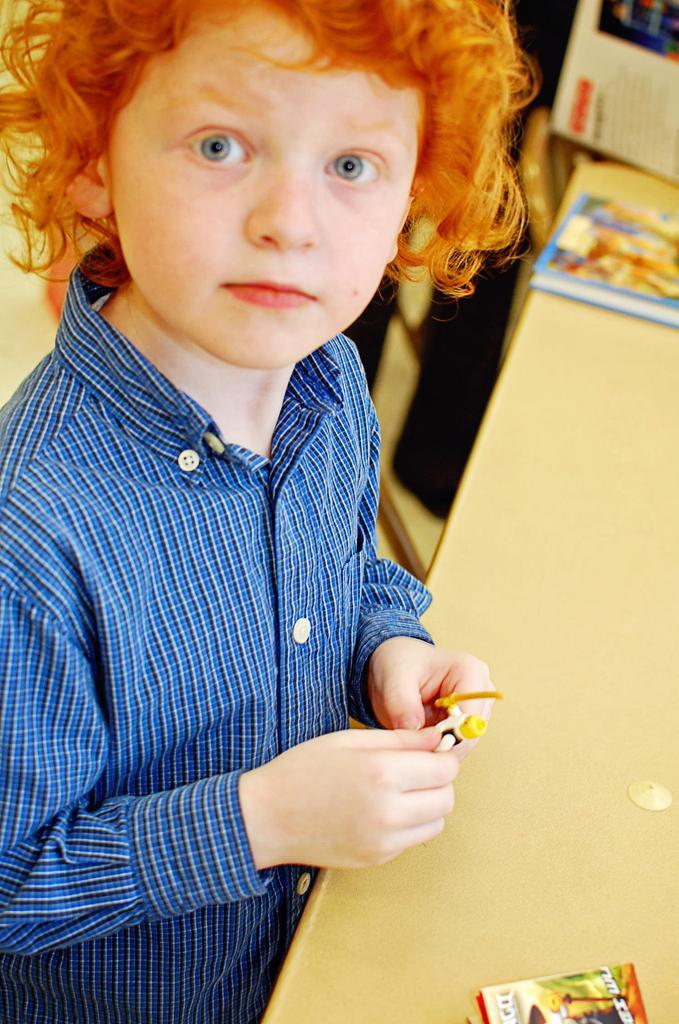How would you summarize this image in a sentence or two? In this image we can see a boy, he is holding a toy, in front of him there is a table, on that there are books, and the background is blurred. 